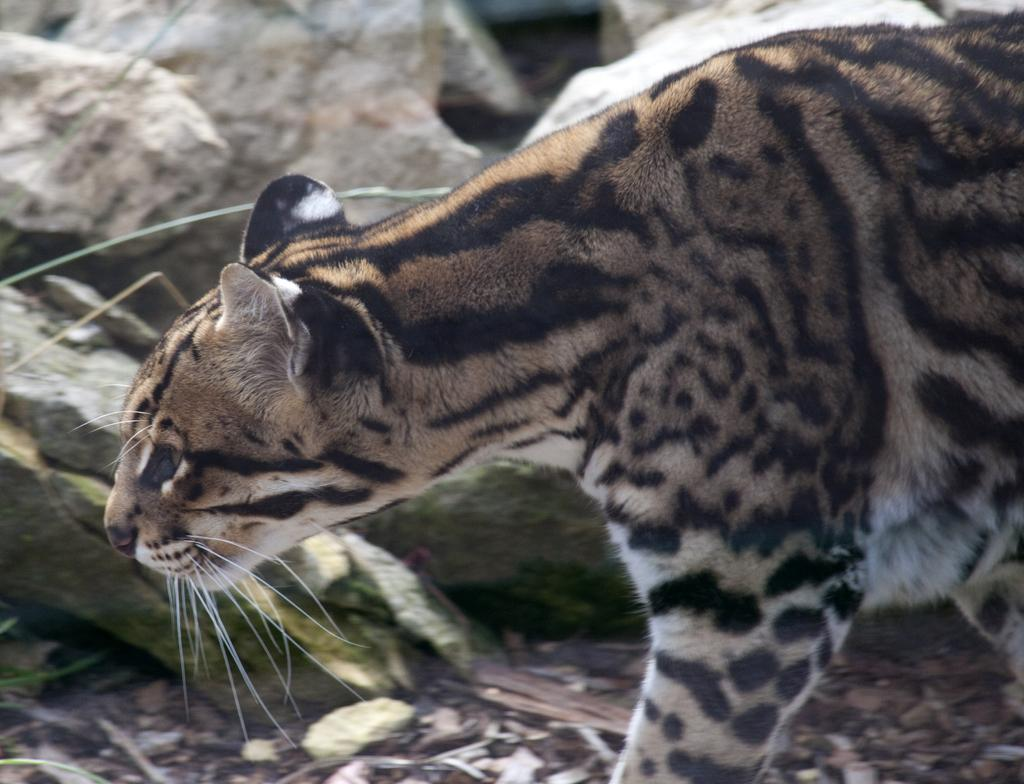What type of creature is in the image? There is an animal in the image. Where is the animal located? The animal is on the ground. What can be seen in the background of the image? There are rocks visible in the background of the image. What word is the animal learning in the image? There is no indication in the image that the animal is learning any words. 